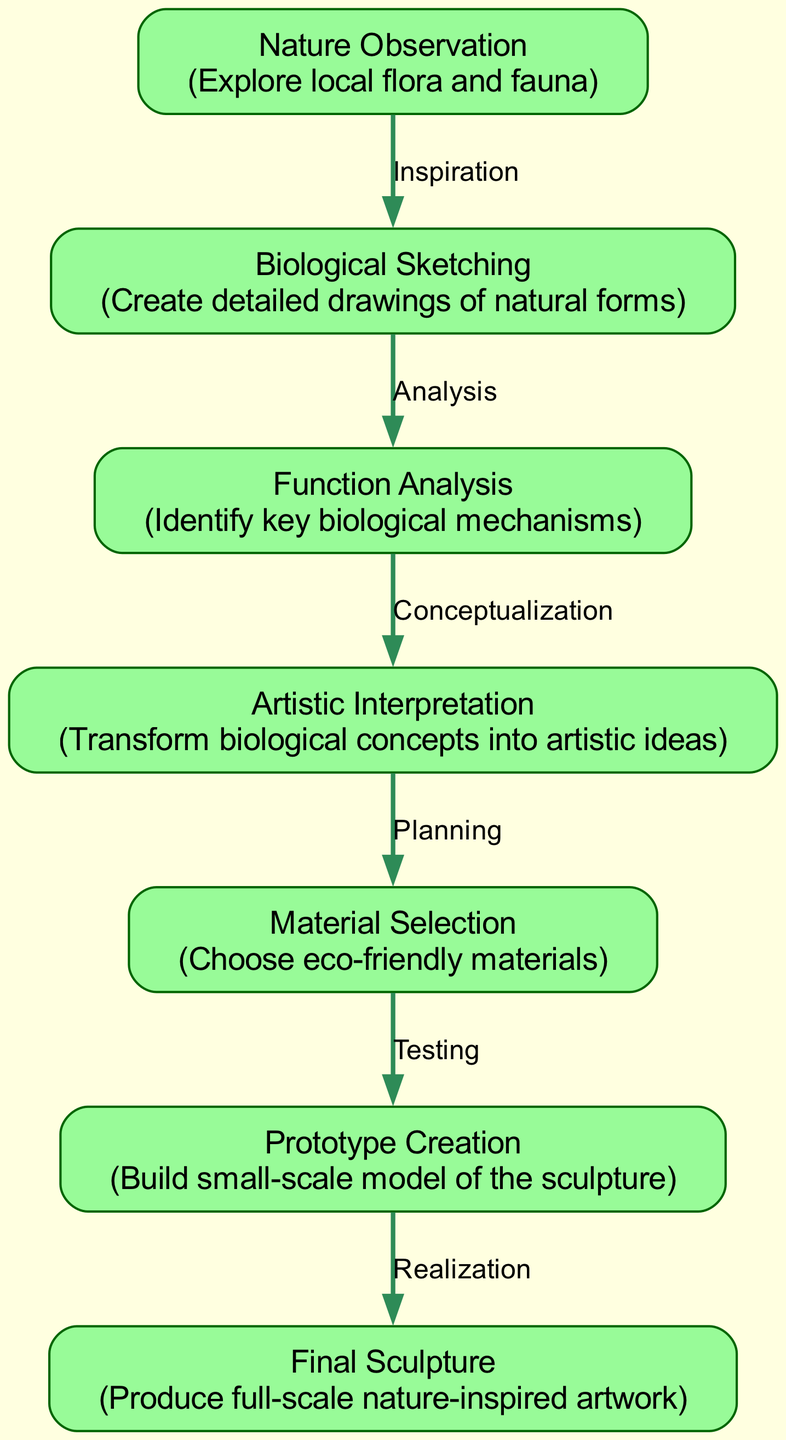What is the first node in the diagram? The first node, labeled "Nature Observation," indicates the initial step of the design process where the artist explores local flora and fauna.
Answer: Nature Observation How many nodes are present in the diagram? The diagram contains a total of seven nodes, each representing a different stage in the biomimetic design process.
Answer: 7 What process follows "Biological Sketching"? According to the edges in the diagram, the process that follows "Biological Sketching" is "Function Analysis," which involves identifying key biological mechanisms.
Answer: Function Analysis Which node represents the final product? "Final Sculpture" is the last node in the diagram, signifying the completion of the nature-inspired artwork after all previous stages have been completed.
Answer: Final Sculpture What is the relationship between "Function Analysis" and "Artistic Interpretation"? The relationship is labeled "Conceptualization," indicating that the identification of biological mechanisms leads to the transformation of these concepts into artistic ideas.
Answer: Conceptualization What kind of materials are chosen in the "Material Selection" stage? The description for "Material Selection" specifies the choice of eco-friendly materials, emphasizing sustainability in the design process.
Answer: Eco-friendly materials Which node precedes "Prototype Creation"? The node that comes before "Prototype Creation" is "Material Selection," where the artist selects the materials before building a model of the sculpture.
Answer: Material Selection How do the edges relate to the stages in the design process? Each edge denotes a significant relationship between the stages, describing the flow of the design process from observation to the final product, illustrating inspiration, analysis, conceptualization, planning, testing, and realization.
Answer: Describe the flow of the design process 